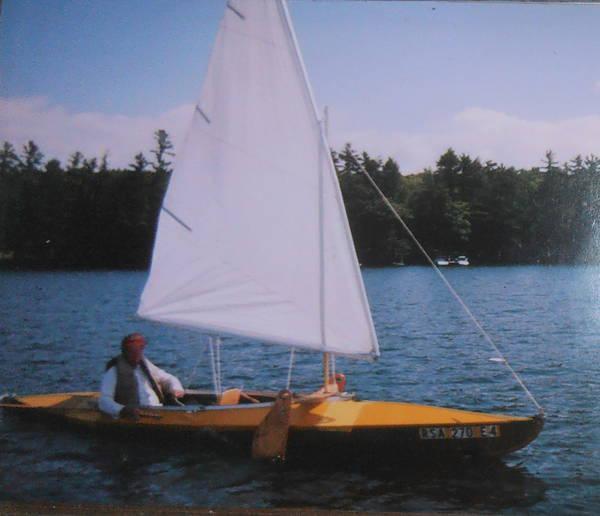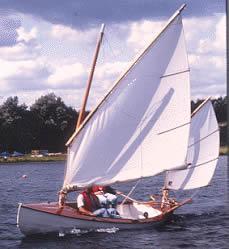The first image is the image on the left, the second image is the image on the right. Considering the images on both sides, is "There is people sailing in the center of each image." valid? Answer yes or no. Yes. The first image is the image on the left, the second image is the image on the right. Given the left and right images, does the statement "There is atleast one boat with numbers or letters on the sail" hold true? Answer yes or no. No. 